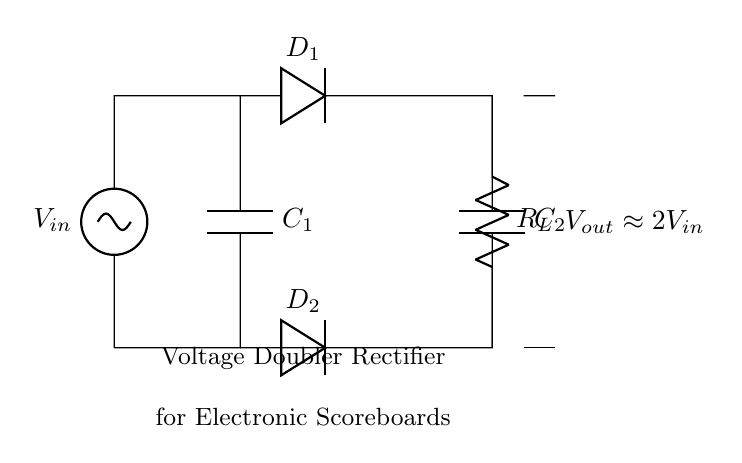What is the function of the components labeled C1 and C2? The capacitors C1 and C2 serve to store electrical energy, allowing the circuit to effectively double the input voltage by charging and discharging in conjunction with the diodes.
Answer: Store energy What types of components are D1 and D2? D1 and D2 are diodes that allow current to flow in one direction only, facilitating the voltage doubling process by rectifying the AC input to provide a DC output.
Answer: Diodes What is the approximate output voltage of this circuit? The circuit diagram notes the output voltage as approximately double the input voltage, thus indicating that if the input is 5V, the output would be around 10V.
Answer: Approximately 2V_in What is the role of the resistor labeled RL? The resistor RL acts as a load that consumes the output voltage for functioning, providing a pathway for the current to flow in the circuit.
Answer: Load How does this circuit achieve voltage doubling? The voltage doubler effect is achieved by two capacitors charging in sequence through the diodes and discharging in a way that combines their voltages, effectively providing an output voltage twice that of the input.
Answer: By combining capacitor voltages What happens when the input voltage increases? An increase in the input voltage would lead to a proportional increase in the output voltage, as the output is designed to be approximately double the input according to the circuit configuration.
Answer: Increases output voltage 